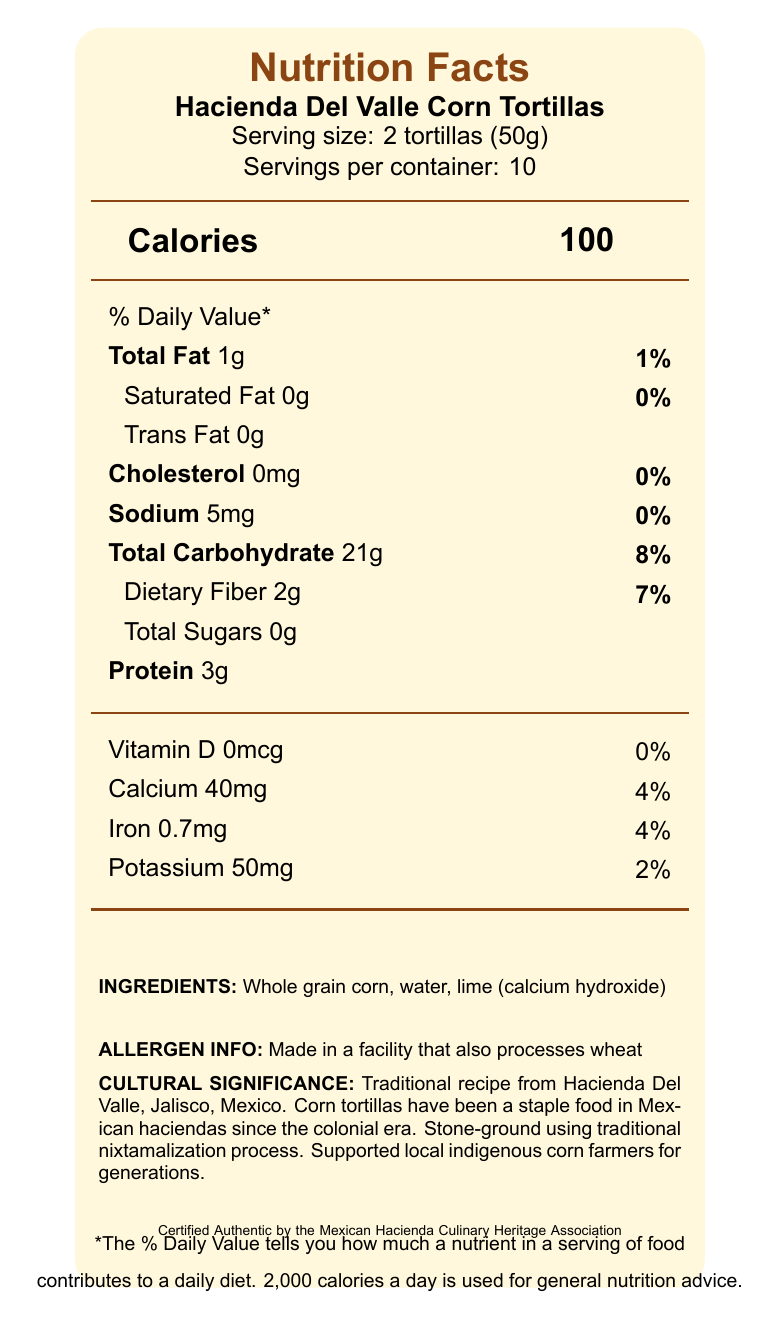what is the serving size for Hacienda Del Valle Corn Tortillas? The serving size is clearly indicated as "2 tortillas (50g)" near the top of the document.
Answer: 2 tortillas (50g) how many servings are there per container? The document states "Servings per container: 10" under the product name and serving size information.
Answer: 10 what is the amount of dietary fiber in one serving? Under the nutritional information, it lists "Dietary Fiber 2g" under "Total Carbohydrate".
Answer: 2g what process is used to stone-grind these tortillas? The "Cultural Significance" section mentions that the tortillas are "Stone-ground using traditional nixtamalization process".
Answer: Nixtamalization how much protein is there in one serving? The nutritional information section lists "Protein 3g".
Answer: 3g these corn tortillas are free from which type of fat? A. Saturated Fat B. Trans Fat C. Both The nutritional information section lists both saturated fat and trans fat as 0g, indicating that the tortillas are free from both types of fat.
Answer: C which of the following minerals is highest in one serving of the tortillas? i. Calcium ii. Iron iii. Potassium The document lists calcium as 40mg, iron as 0.7mg, and potassium as 50mg. 40mg of calcium contributes to 4% of the daily value which is the highest among the listed minerals.
Answer: i. Calcium Is there any cholesterol in these tortillas? The nutritional information section shows "Cholesterol 0mg", indicating there is no cholesterol.
Answer: No summarize the cultural significance of these tortillas. The document's "Cultural Significance" section provides details on the origin, historical context, preparation method, social impact, and certification that highlights the traditional and cultural importance of these tortillas.
Answer: Traditional recipe from Hacienda Del Valle, Jalisco, Mexico, corn tortillas have been a staple food in Mexican haciendas since the colonial era. Stone-ground using traditional nixtamalization process, they have supported local indigenous corn farmers for generations. Certified Authentic by the Mexican Hacienda Culinary Heritage Association. who certified the authenticity of these tortillas? The bottom of the document mentions, "Certified Authentic by the Mexican Hacienda Culinary Heritage Association".
Answer: Mexican Hacienda Culinary Heritage Association what flavor varieties are available for these tortillas? The document does not provide any information about different flavor varieties available for these tortillas.
Answer: Not enough information 